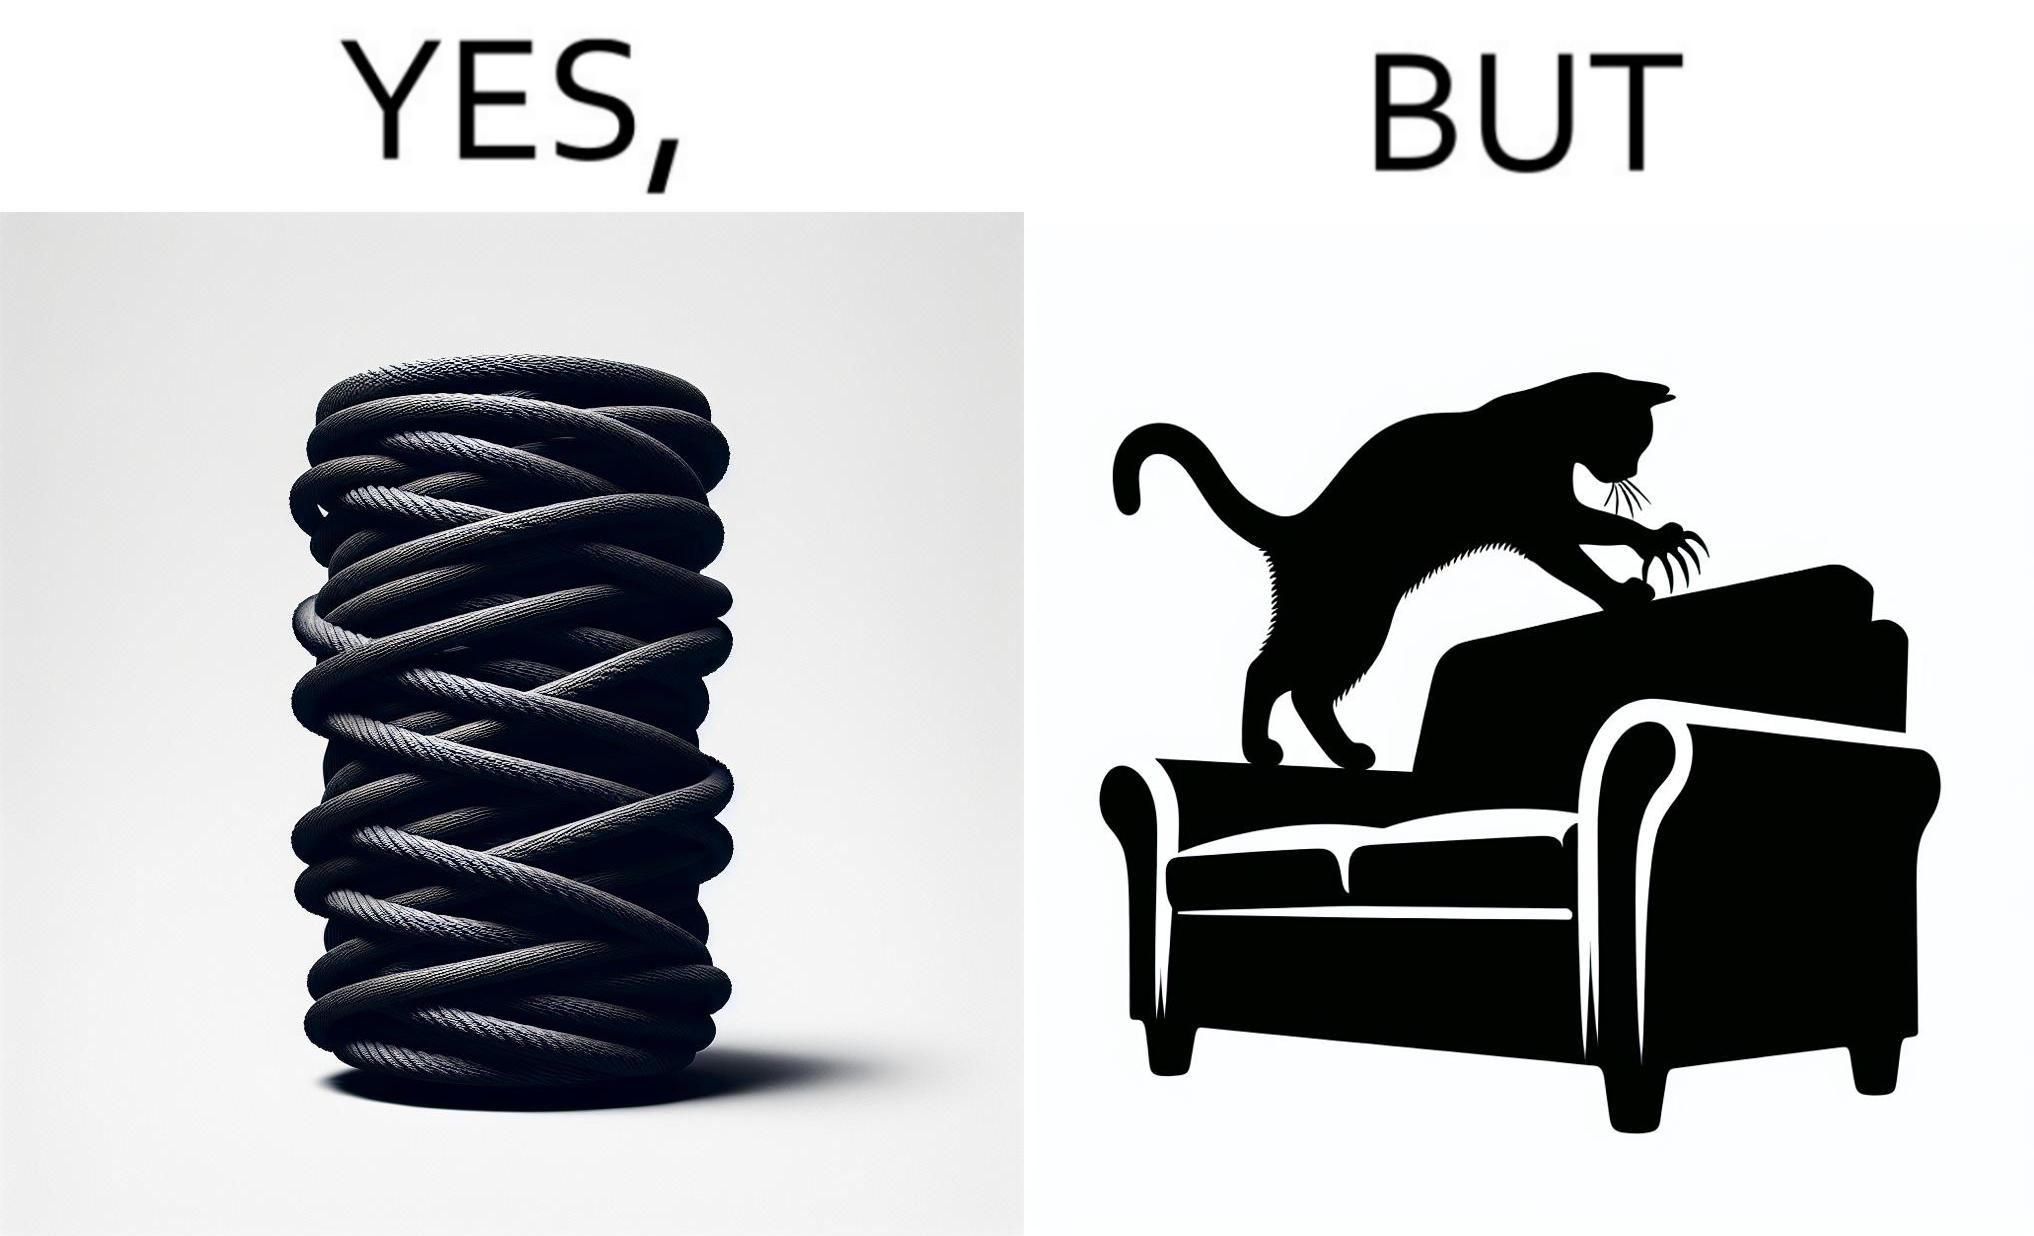What is shown in the left half versus the right half of this image? In the left part of the image: a cylindrical toy or some sort of thing  with a lots of rope wounded around its surface In the right part of the image: a cat scratching its nails over the sides of a sofa or trying to climb up the sofa 